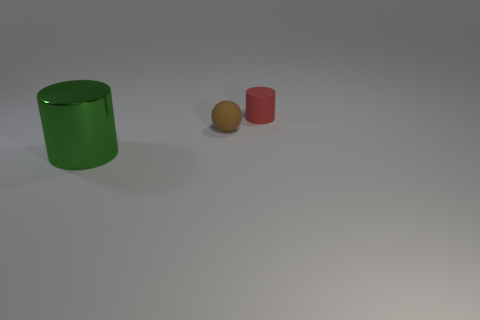Add 3 small rubber balls. How many objects exist? 6 Subtract all cylinders. How many objects are left? 1 Add 1 small brown things. How many small brown things exist? 2 Subtract 1 brown balls. How many objects are left? 2 Subtract all big metal things. Subtract all big objects. How many objects are left? 1 Add 3 small objects. How many small objects are left? 5 